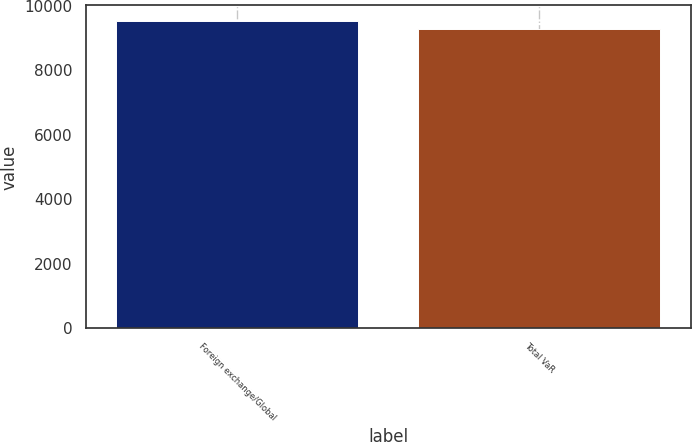Convert chart. <chart><loc_0><loc_0><loc_500><loc_500><bar_chart><fcel>Foreign exchange/Global<fcel>Total VaR<nl><fcel>9543<fcel>9288<nl></chart> 